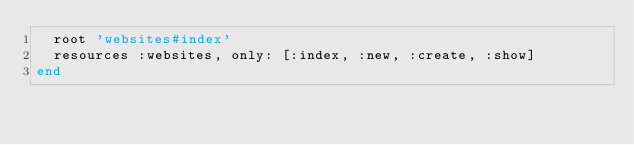<code> <loc_0><loc_0><loc_500><loc_500><_Ruby_>  root 'websites#index'
  resources :websites, only: [:index, :new, :create, :show]
end
</code> 